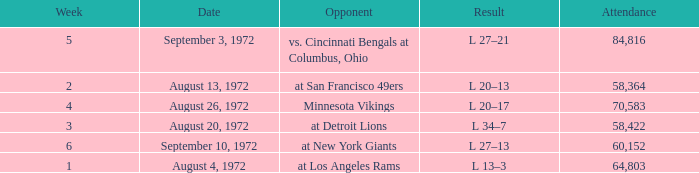What is the date of week 4? August 26, 1972. 